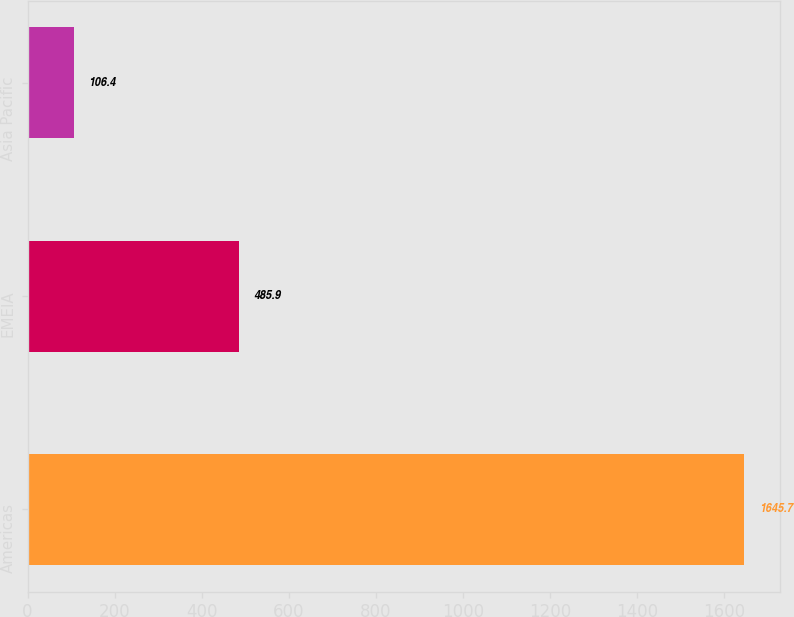Convert chart. <chart><loc_0><loc_0><loc_500><loc_500><bar_chart><fcel>Americas<fcel>EMEIA<fcel>Asia Pacific<nl><fcel>1645.7<fcel>485.9<fcel>106.4<nl></chart> 